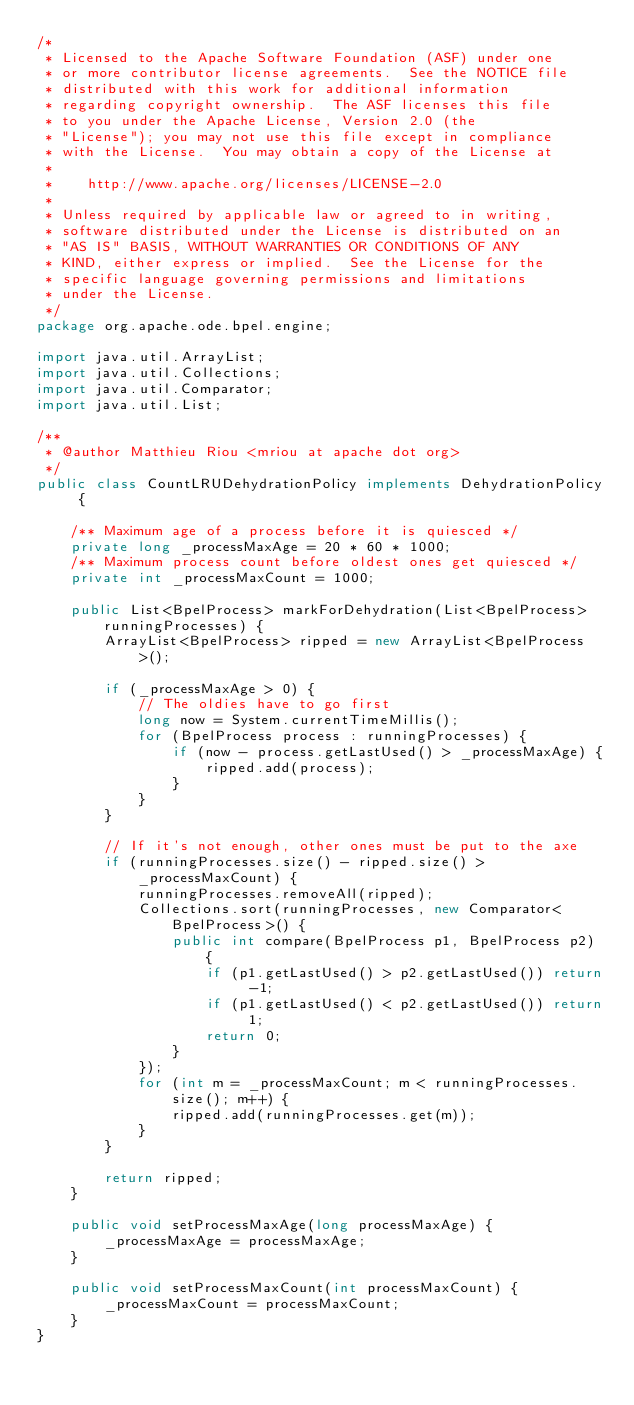<code> <loc_0><loc_0><loc_500><loc_500><_Java_>/*
 * Licensed to the Apache Software Foundation (ASF) under one
 * or more contributor license agreements.  See the NOTICE file
 * distributed with this work for additional information
 * regarding copyright ownership.  The ASF licenses this file
 * to you under the Apache License, Version 2.0 (the
 * "License"); you may not use this file except in compliance
 * with the License.  You may obtain a copy of the License at
 *
 *    http://www.apache.org/licenses/LICENSE-2.0
 *
 * Unless required by applicable law or agreed to in writing,
 * software distributed under the License is distributed on an
 * "AS IS" BASIS, WITHOUT WARRANTIES OR CONDITIONS OF ANY
 * KIND, either express or implied.  See the License for the
 * specific language governing permissions and limitations
 * under the License.
 */
package org.apache.ode.bpel.engine;

import java.util.ArrayList;
import java.util.Collections;
import java.util.Comparator;
import java.util.List;

/**
 * @author Matthieu Riou <mriou at apache dot org>
 */
public class CountLRUDehydrationPolicy implements DehydrationPolicy {

    /** Maximum age of a process before it is quiesced */
    private long _processMaxAge = 20 * 60 * 1000;
    /** Maximum process count before oldest ones get quiesced */
    private int _processMaxCount = 1000;

    public List<BpelProcess> markForDehydration(List<BpelProcess> runningProcesses) {
        ArrayList<BpelProcess> ripped = new ArrayList<BpelProcess>();

        if (_processMaxAge > 0) {
            // The oldies have to go first
            long now = System.currentTimeMillis();
            for (BpelProcess process : runningProcesses) {
                if (now - process.getLastUsed() > _processMaxAge) {
                    ripped.add(process);
                }
            }
        }

        // If it's not enough, other ones must be put to the axe
        if (runningProcesses.size() - ripped.size() > _processMaxCount) {
            runningProcesses.removeAll(ripped);
            Collections.sort(runningProcesses, new Comparator<BpelProcess>() {
                public int compare(BpelProcess p1, BpelProcess p2) {
                    if (p1.getLastUsed() > p2.getLastUsed()) return -1;
                    if (p1.getLastUsed() < p2.getLastUsed()) return 1;
                    return 0;
                }
            });
            for (int m = _processMaxCount; m < runningProcesses.size(); m++) {
                ripped.add(runningProcesses.get(m));
            }
        }

        return ripped;
    }

    public void setProcessMaxAge(long processMaxAge) {
        _processMaxAge = processMaxAge;
    }

    public void setProcessMaxCount(int processMaxCount) {
        _processMaxCount = processMaxCount;
    }
}
</code> 